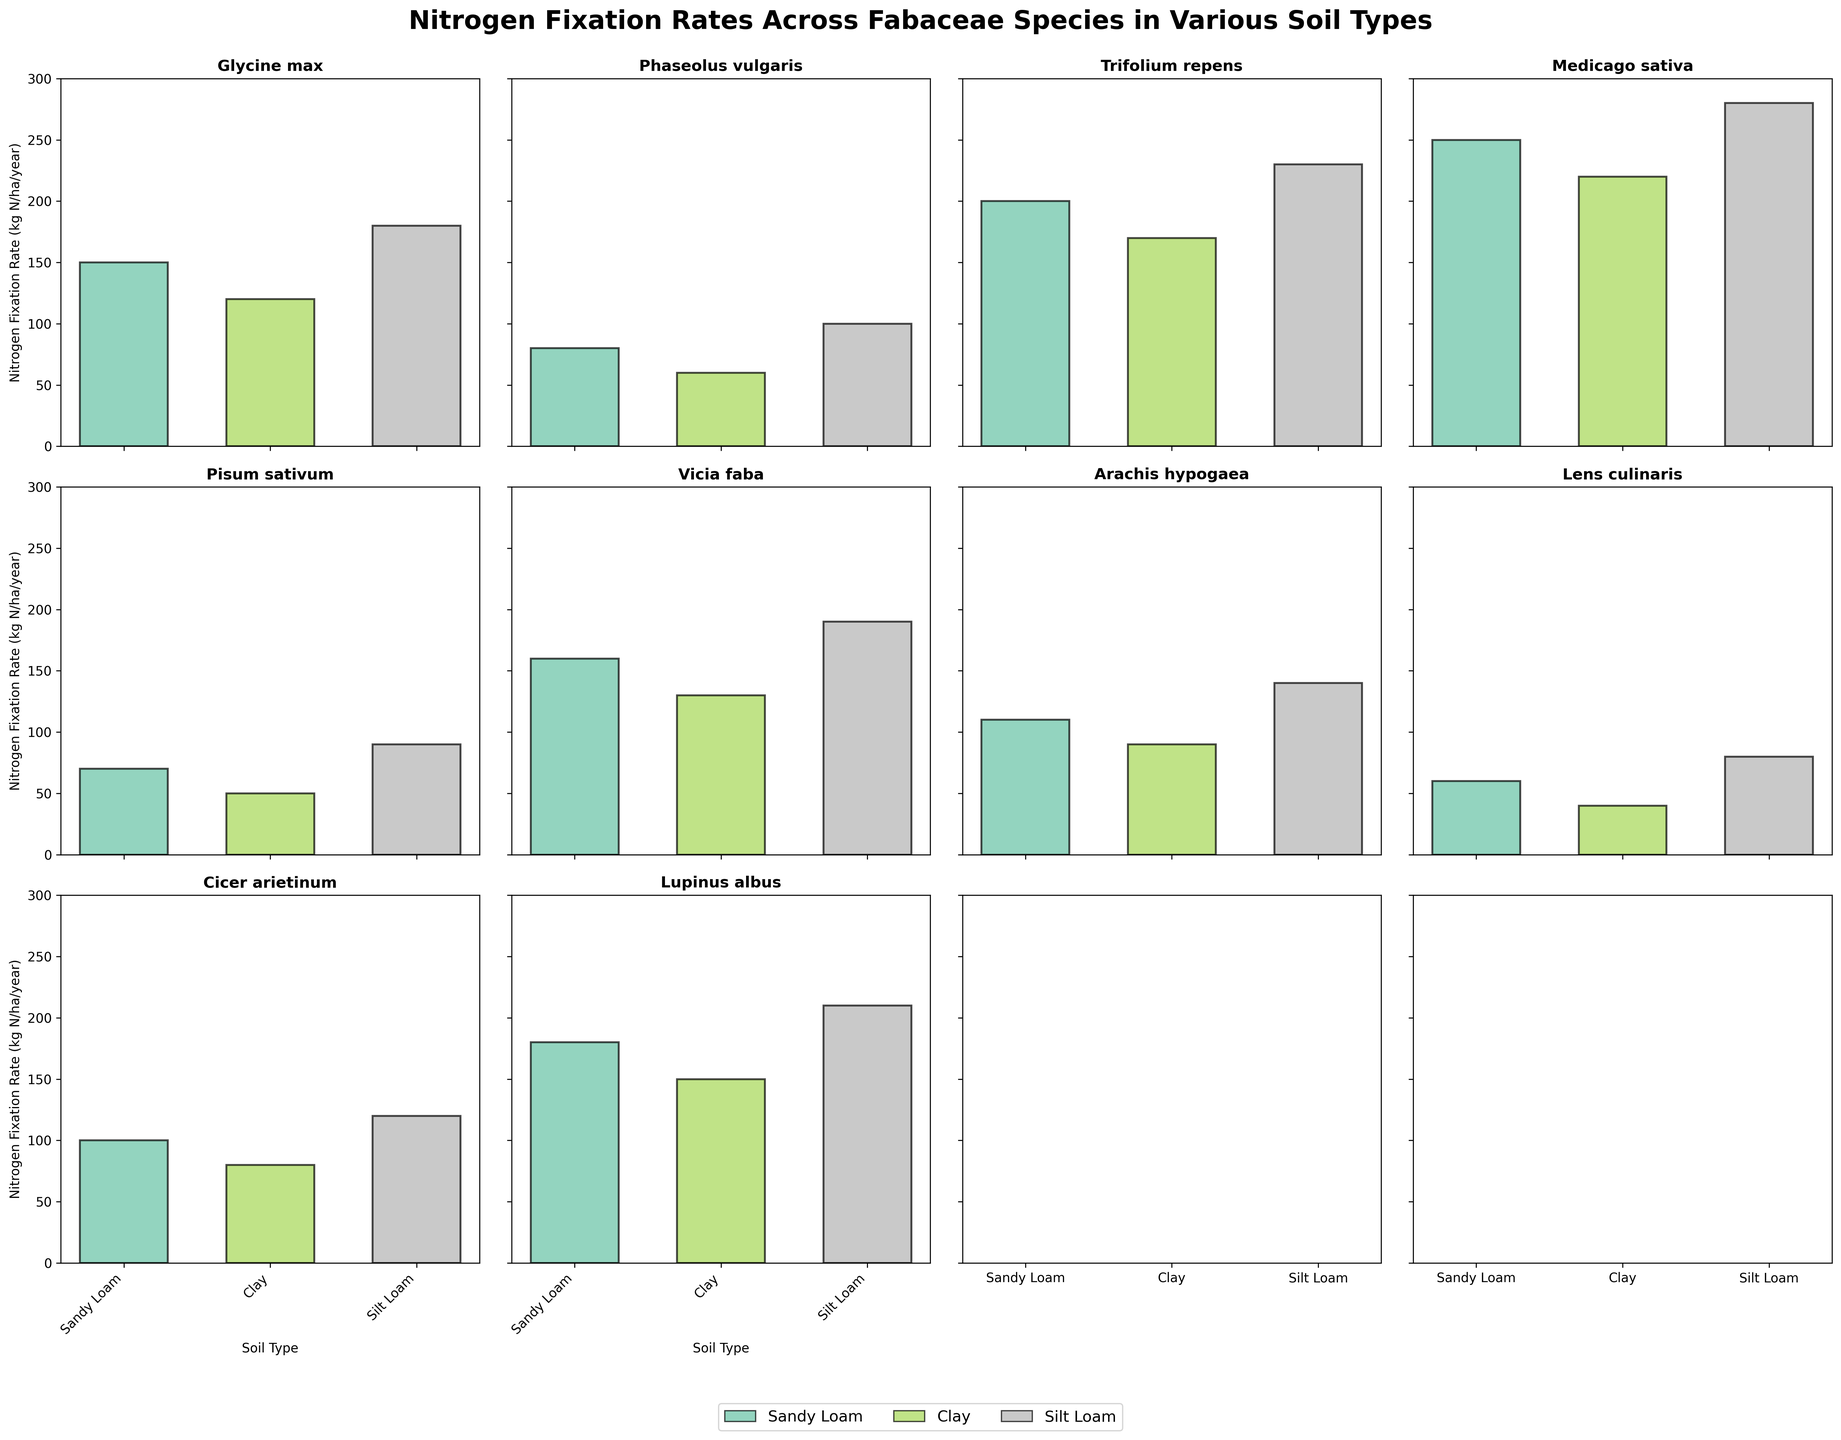What is the highest nitrogen fixation rate among all the species? By examining each subplot, we can see that the species with the highest nitrogen fixation rate is Medicago sativa in Silt Loam soil at 280 kg N/ha/year.
Answer: 280 kg N/ha/year Which species shows the lowest nitrogen fixation rate in any soil type? Observing all the subplots, Lens culinaris in Clay soil demonstrates the lowest nitrogen fixation rate at 40 kg N/ha/year.
Answer: 40 kg N/ha/year For Glycine max, what is the difference in nitrogen fixation rate between Silt Loam soil and Clay soil? Glycine max has nitrogen fixation rates of 180 kg N/ha/year in Silt Loam soil and 120 kg N/ha/year in Clay soil. The difference is 180 - 120 = 60 kg N/ha/year.
Answer: 60 kg N/ha/year Which soil type, on average, has the highest nitrogen fixation rate across all species? First, sum the nitrogen fixation rates for each soil type across all species: 
Sandy Loam (150+80+200+250+70+160+110+60+100+180), Clay (120+60+170+220+50+130+90+40+80+150), Silt Loam (180+100+230+280+90+190+140+80+120+210). Then, calculate the average:
Sandy Loam: 1660 / 10 = 166
Clay: 1310 / 10 = 131
Silt Loam: 1720 / 10 = 172. 
So, Silt Loam has the highest average nitrogen fixation rate.
Answer: Silt Loam Compare the nitrogen fixation rates of Vicia faba across different soil types. What do you observe? Vicia faba has nitrogen fixation rates of 160 kg N/ha/year in Sandy Loam, 130 kg N/ha/year in Clay, and 190 kg N/ha/year in Silt Loam. Observing these values, we see that Silt Loam has the highest rate and Clay has the lowest.
Answer: Silt Loam > Sandy Loam > Clay Which species demonstrates the most variation in nitrogen fixation rates across the different soil types? By comparing the ranges of nitrogen fixation rates (difference between maximum and minimum) for each species, Medicago sativa shows the largest range: 280 (Silt Loam) - 220 (Clay) = 60.
Answer: Medicago sativa In which soil type does Trifolium repens have its highest nitrogen fixation rate? In the Trifolium repens subplot, the Silt Loam soil type has the highest bar at 230 kg N/ha/year.
Answer: Silt Loam What is the average nitrogen fixation rate for Arachis hypogaea across all soil types? Arachis hypogaea has nitrogen fixation rates of 110 kg N/ha/year (Sandy Loam), 90 kg N/ha/year (Clay), and 140 kg N/ha/year (Silt Loam). The average is (110 + 90 + 140) / 3 = 113.33 kg N/ha/year.
Answer: 113.33 kg N/ha/year How does the nitrogen fixation rate of Lupinus albus in Clay soil compare to that of Medicago sativa in the same soil? Lupinus albus has a nitrogen fixation rate of 150 kg N/ha/year in Clay soil, while Medicago sativa has a rate of 220 kg N/ha/year in Clay soil. Comparing these values, Medicago sativa has a higher rate.
Answer: Medicago sativa > Lupinus albus 